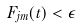<formula> <loc_0><loc_0><loc_500><loc_500>F _ { j m } ( t ) < \epsilon</formula> 